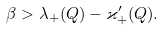Convert formula to latex. <formula><loc_0><loc_0><loc_500><loc_500>\beta > \lambda _ { + } ( Q ) - \varkappa _ { + } ^ { \prime } ( Q ) .</formula> 